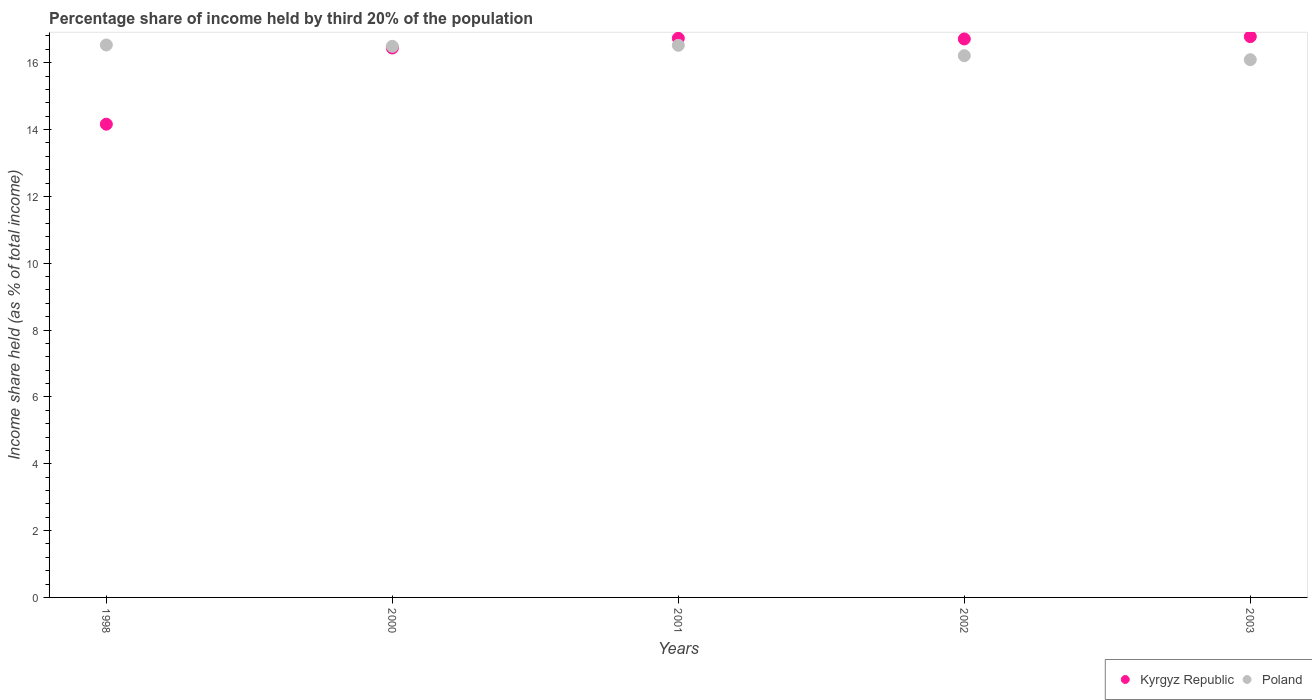How many different coloured dotlines are there?
Make the answer very short. 2. Is the number of dotlines equal to the number of legend labels?
Your response must be concise. Yes. What is the share of income held by third 20% of the population in Poland in 2000?
Ensure brevity in your answer.  16.49. Across all years, what is the maximum share of income held by third 20% of the population in Poland?
Offer a terse response. 16.53. Across all years, what is the minimum share of income held by third 20% of the population in Poland?
Your answer should be compact. 16.09. In which year was the share of income held by third 20% of the population in Kyrgyz Republic maximum?
Make the answer very short. 2003. In which year was the share of income held by third 20% of the population in Kyrgyz Republic minimum?
Your answer should be compact. 1998. What is the total share of income held by third 20% of the population in Poland in the graph?
Offer a very short reply. 81.84. What is the difference between the share of income held by third 20% of the population in Kyrgyz Republic in 2002 and that in 2003?
Your answer should be very brief. -0.07. What is the difference between the share of income held by third 20% of the population in Kyrgyz Republic in 1998 and the share of income held by third 20% of the population in Poland in 2003?
Offer a very short reply. -1.93. What is the average share of income held by third 20% of the population in Poland per year?
Your answer should be compact. 16.37. In the year 2001, what is the difference between the share of income held by third 20% of the population in Kyrgyz Republic and share of income held by third 20% of the population in Poland?
Offer a terse response. 0.21. In how many years, is the share of income held by third 20% of the population in Poland greater than 2 %?
Offer a terse response. 5. What is the ratio of the share of income held by third 20% of the population in Poland in 1998 to that in 2001?
Provide a succinct answer. 1. Is the difference between the share of income held by third 20% of the population in Kyrgyz Republic in 2001 and 2002 greater than the difference between the share of income held by third 20% of the population in Poland in 2001 and 2002?
Provide a short and direct response. No. What is the difference between the highest and the second highest share of income held by third 20% of the population in Kyrgyz Republic?
Offer a very short reply. 0.05. What is the difference between the highest and the lowest share of income held by third 20% of the population in Poland?
Provide a short and direct response. 0.44. Is the sum of the share of income held by third 20% of the population in Poland in 2001 and 2003 greater than the maximum share of income held by third 20% of the population in Kyrgyz Republic across all years?
Offer a very short reply. Yes. Is the share of income held by third 20% of the population in Kyrgyz Republic strictly less than the share of income held by third 20% of the population in Poland over the years?
Give a very brief answer. No. What is the difference between two consecutive major ticks on the Y-axis?
Your answer should be compact. 2. Are the values on the major ticks of Y-axis written in scientific E-notation?
Provide a succinct answer. No. Does the graph contain grids?
Offer a very short reply. No. Where does the legend appear in the graph?
Offer a very short reply. Bottom right. How are the legend labels stacked?
Provide a succinct answer. Horizontal. What is the title of the graph?
Give a very brief answer. Percentage share of income held by third 20% of the population. Does "Hungary" appear as one of the legend labels in the graph?
Keep it short and to the point. No. What is the label or title of the X-axis?
Provide a succinct answer. Years. What is the label or title of the Y-axis?
Your response must be concise. Income share held (as % of total income). What is the Income share held (as % of total income) of Kyrgyz Republic in 1998?
Provide a short and direct response. 14.16. What is the Income share held (as % of total income) in Poland in 1998?
Your answer should be compact. 16.53. What is the Income share held (as % of total income) of Kyrgyz Republic in 2000?
Make the answer very short. 16.44. What is the Income share held (as % of total income) of Poland in 2000?
Keep it short and to the point. 16.49. What is the Income share held (as % of total income) of Kyrgyz Republic in 2001?
Keep it short and to the point. 16.73. What is the Income share held (as % of total income) of Poland in 2001?
Provide a short and direct response. 16.52. What is the Income share held (as % of total income) in Kyrgyz Republic in 2002?
Make the answer very short. 16.71. What is the Income share held (as % of total income) of Poland in 2002?
Offer a terse response. 16.21. What is the Income share held (as % of total income) of Kyrgyz Republic in 2003?
Offer a very short reply. 16.78. What is the Income share held (as % of total income) of Poland in 2003?
Offer a terse response. 16.09. Across all years, what is the maximum Income share held (as % of total income) in Kyrgyz Republic?
Make the answer very short. 16.78. Across all years, what is the maximum Income share held (as % of total income) of Poland?
Give a very brief answer. 16.53. Across all years, what is the minimum Income share held (as % of total income) in Kyrgyz Republic?
Ensure brevity in your answer.  14.16. Across all years, what is the minimum Income share held (as % of total income) in Poland?
Provide a short and direct response. 16.09. What is the total Income share held (as % of total income) of Kyrgyz Republic in the graph?
Your answer should be compact. 80.82. What is the total Income share held (as % of total income) in Poland in the graph?
Offer a very short reply. 81.84. What is the difference between the Income share held (as % of total income) of Kyrgyz Republic in 1998 and that in 2000?
Offer a very short reply. -2.28. What is the difference between the Income share held (as % of total income) in Kyrgyz Republic in 1998 and that in 2001?
Ensure brevity in your answer.  -2.57. What is the difference between the Income share held (as % of total income) in Poland in 1998 and that in 2001?
Give a very brief answer. 0.01. What is the difference between the Income share held (as % of total income) in Kyrgyz Republic in 1998 and that in 2002?
Offer a terse response. -2.55. What is the difference between the Income share held (as % of total income) in Poland in 1998 and that in 2002?
Offer a very short reply. 0.32. What is the difference between the Income share held (as % of total income) of Kyrgyz Republic in 1998 and that in 2003?
Ensure brevity in your answer.  -2.62. What is the difference between the Income share held (as % of total income) in Poland in 1998 and that in 2003?
Your response must be concise. 0.44. What is the difference between the Income share held (as % of total income) of Kyrgyz Republic in 2000 and that in 2001?
Ensure brevity in your answer.  -0.29. What is the difference between the Income share held (as % of total income) in Poland in 2000 and that in 2001?
Ensure brevity in your answer.  -0.03. What is the difference between the Income share held (as % of total income) in Kyrgyz Republic in 2000 and that in 2002?
Your answer should be compact. -0.27. What is the difference between the Income share held (as % of total income) in Poland in 2000 and that in 2002?
Offer a very short reply. 0.28. What is the difference between the Income share held (as % of total income) of Kyrgyz Republic in 2000 and that in 2003?
Your answer should be very brief. -0.34. What is the difference between the Income share held (as % of total income) of Kyrgyz Republic in 2001 and that in 2002?
Provide a short and direct response. 0.02. What is the difference between the Income share held (as % of total income) in Poland in 2001 and that in 2002?
Ensure brevity in your answer.  0.31. What is the difference between the Income share held (as % of total income) of Poland in 2001 and that in 2003?
Give a very brief answer. 0.43. What is the difference between the Income share held (as % of total income) of Kyrgyz Republic in 2002 and that in 2003?
Your answer should be compact. -0.07. What is the difference between the Income share held (as % of total income) in Poland in 2002 and that in 2003?
Provide a succinct answer. 0.12. What is the difference between the Income share held (as % of total income) in Kyrgyz Republic in 1998 and the Income share held (as % of total income) in Poland in 2000?
Give a very brief answer. -2.33. What is the difference between the Income share held (as % of total income) of Kyrgyz Republic in 1998 and the Income share held (as % of total income) of Poland in 2001?
Provide a short and direct response. -2.36. What is the difference between the Income share held (as % of total income) of Kyrgyz Republic in 1998 and the Income share held (as % of total income) of Poland in 2002?
Ensure brevity in your answer.  -2.05. What is the difference between the Income share held (as % of total income) of Kyrgyz Republic in 1998 and the Income share held (as % of total income) of Poland in 2003?
Offer a terse response. -1.93. What is the difference between the Income share held (as % of total income) of Kyrgyz Republic in 2000 and the Income share held (as % of total income) of Poland in 2001?
Ensure brevity in your answer.  -0.08. What is the difference between the Income share held (as % of total income) of Kyrgyz Republic in 2000 and the Income share held (as % of total income) of Poland in 2002?
Make the answer very short. 0.23. What is the difference between the Income share held (as % of total income) in Kyrgyz Republic in 2001 and the Income share held (as % of total income) in Poland in 2002?
Offer a terse response. 0.52. What is the difference between the Income share held (as % of total income) of Kyrgyz Republic in 2001 and the Income share held (as % of total income) of Poland in 2003?
Make the answer very short. 0.64. What is the difference between the Income share held (as % of total income) of Kyrgyz Republic in 2002 and the Income share held (as % of total income) of Poland in 2003?
Ensure brevity in your answer.  0.62. What is the average Income share held (as % of total income) in Kyrgyz Republic per year?
Give a very brief answer. 16.16. What is the average Income share held (as % of total income) in Poland per year?
Give a very brief answer. 16.37. In the year 1998, what is the difference between the Income share held (as % of total income) of Kyrgyz Republic and Income share held (as % of total income) of Poland?
Ensure brevity in your answer.  -2.37. In the year 2001, what is the difference between the Income share held (as % of total income) of Kyrgyz Republic and Income share held (as % of total income) of Poland?
Provide a short and direct response. 0.21. In the year 2003, what is the difference between the Income share held (as % of total income) in Kyrgyz Republic and Income share held (as % of total income) in Poland?
Make the answer very short. 0.69. What is the ratio of the Income share held (as % of total income) of Kyrgyz Republic in 1998 to that in 2000?
Provide a succinct answer. 0.86. What is the ratio of the Income share held (as % of total income) of Poland in 1998 to that in 2000?
Offer a very short reply. 1. What is the ratio of the Income share held (as % of total income) in Kyrgyz Republic in 1998 to that in 2001?
Your answer should be compact. 0.85. What is the ratio of the Income share held (as % of total income) in Poland in 1998 to that in 2001?
Ensure brevity in your answer.  1. What is the ratio of the Income share held (as % of total income) in Kyrgyz Republic in 1998 to that in 2002?
Ensure brevity in your answer.  0.85. What is the ratio of the Income share held (as % of total income) of Poland in 1998 to that in 2002?
Ensure brevity in your answer.  1.02. What is the ratio of the Income share held (as % of total income) of Kyrgyz Republic in 1998 to that in 2003?
Your answer should be compact. 0.84. What is the ratio of the Income share held (as % of total income) in Poland in 1998 to that in 2003?
Offer a terse response. 1.03. What is the ratio of the Income share held (as % of total income) in Kyrgyz Republic in 2000 to that in 2001?
Give a very brief answer. 0.98. What is the ratio of the Income share held (as % of total income) of Poland in 2000 to that in 2001?
Your answer should be compact. 1. What is the ratio of the Income share held (as % of total income) in Kyrgyz Republic in 2000 to that in 2002?
Keep it short and to the point. 0.98. What is the ratio of the Income share held (as % of total income) in Poland in 2000 to that in 2002?
Your answer should be compact. 1.02. What is the ratio of the Income share held (as % of total income) in Kyrgyz Republic in 2000 to that in 2003?
Provide a short and direct response. 0.98. What is the ratio of the Income share held (as % of total income) of Poland in 2000 to that in 2003?
Ensure brevity in your answer.  1.02. What is the ratio of the Income share held (as % of total income) in Poland in 2001 to that in 2002?
Provide a short and direct response. 1.02. What is the ratio of the Income share held (as % of total income) of Poland in 2001 to that in 2003?
Offer a terse response. 1.03. What is the ratio of the Income share held (as % of total income) of Kyrgyz Republic in 2002 to that in 2003?
Your response must be concise. 1. What is the ratio of the Income share held (as % of total income) in Poland in 2002 to that in 2003?
Provide a short and direct response. 1.01. What is the difference between the highest and the second highest Income share held (as % of total income) in Kyrgyz Republic?
Your response must be concise. 0.05. What is the difference between the highest and the second highest Income share held (as % of total income) of Poland?
Offer a terse response. 0.01. What is the difference between the highest and the lowest Income share held (as % of total income) of Kyrgyz Republic?
Keep it short and to the point. 2.62. What is the difference between the highest and the lowest Income share held (as % of total income) in Poland?
Provide a succinct answer. 0.44. 